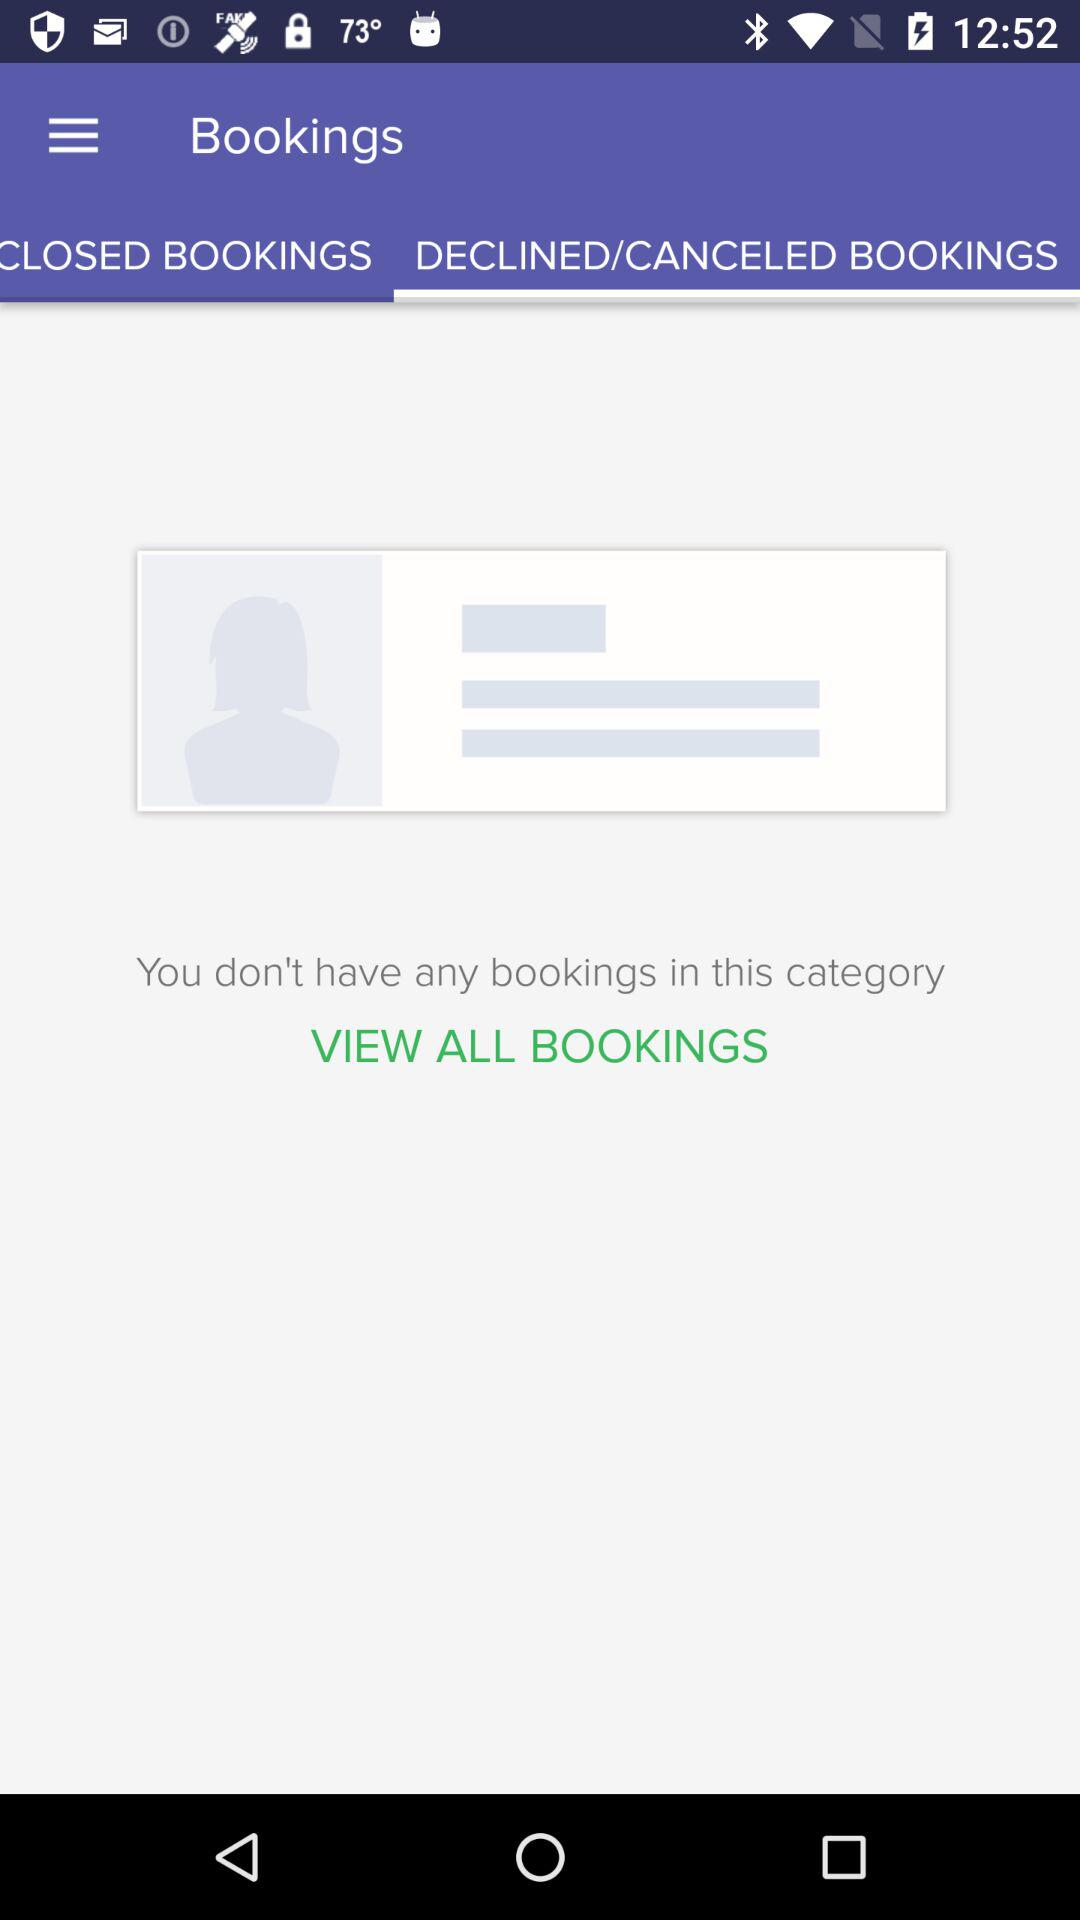How many bookings do I have?
Answer the question using a single word or phrase. 0 